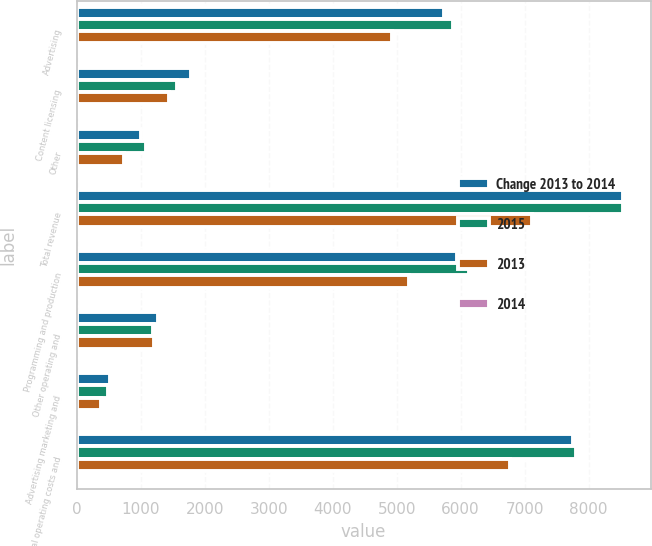Convert chart. <chart><loc_0><loc_0><loc_500><loc_500><stacked_bar_chart><ecel><fcel>Advertising<fcel>Content licensing<fcel>Other<fcel>Total revenue<fcel>Programming and production<fcel>Other operating and<fcel>Advertising marketing and<fcel>Total operating costs and<nl><fcel>Change 2013 to 2014<fcel>5747<fcel>1784<fcel>999<fcel>8530<fcel>5950<fcel>1276<fcel>524<fcel>7750<nl><fcel>2015<fcel>5888<fcel>1569<fcel>1085<fcel>8542<fcel>6127<fcel>1199<fcel>482<fcel>7808<nl><fcel>2013<fcel>4930<fcel>1447<fcel>743<fcel>7120<fcel>5192<fcel>1204<fcel>379<fcel>6775<nl><fcel>2014<fcel>2.4<fcel>13.7<fcel>7.8<fcel>0.1<fcel>2.9<fcel>6.4<fcel>8.9<fcel>0.7<nl></chart> 